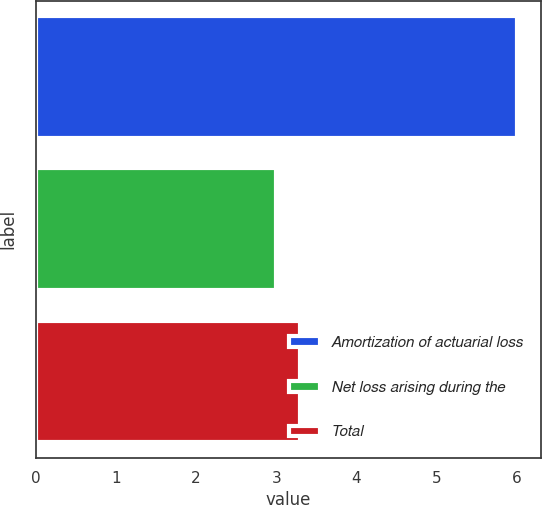Convert chart. <chart><loc_0><loc_0><loc_500><loc_500><bar_chart><fcel>Amortization of actuarial loss<fcel>Net loss arising during the<fcel>Total<nl><fcel>6<fcel>3<fcel>3.3<nl></chart> 